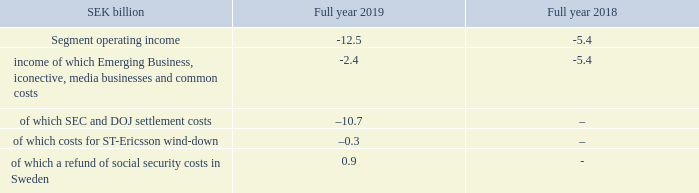Operating income increased to SEK 2.3 (1.1) billion. Operating income excluding restructur- ing charges improved to SEK 2.4 (1.4) billion due to a positive effect from reversal of a provision for impairment of trade receivables made in Q1 2019, of SEK 0.7 billion, and higher gross margin.
Operating margin was 6.3%, excluding restructuring charges and the positive effect from reversal of a provision for impairment of trade receivables of SEK 0.7 billion in Q1 2019.
Restructuring charges amounted to SEK 0.0 (–0.3) billion.
Emerging Business and Other
Segment Emerging Business and Other represented 3% (4%) of Group net sales in 2019.
The segment includes:
–– Emerging Business, including IoT, iconectiv
and New businesses
–– Media businesses, including Red Bee
Media and a 49% ownership of MediaKind.
Net sales
Reported sales decreased by –19% in 2019 due to the 51% divestment of MediaKind in February 2019. Sales adjusted for comparable units and currency increased by 14% driven by growth in the iconectiv business through a multi-year number portability contract in the US.
Gross margin
Gross margin declined mainly due to the 51% divestment of MediaKind. The decline was partly offset by lower restructuring charges.
Operating income (loss)
Operating income was impacted by costs of SEK –10.7 billion related to the resolution of the US SEC and DOJ investigations, a refund of earlier paid social security costs in Sweden of SEK 0.9 billion and by costs of SEK –0.3
billion related to the wind-down of the ST-Ericsson legal structure.
Operating income in Emerging Business, iconectiv and common costs improved, driven by profitable growth in iconectiv. Red Bee Media income improved supported by profit improvement activities. Media Solutions income improved driven by the 51% divestment of Media Kind, including a capital gain from the transaction.
What is the reason that gross margin declined? The 51% divestment of mediakind. What is the full year 2018 operating income?
Answer scale should be: billion. -5.4. What is the full year 2019 operating income?
Answer scale should be: billion. -12.5. What is the total segment operating income for 2019 and 2018?
Answer scale should be: billion. -12.5+(-5.4)
Answer: -17.9. What is the change in income from Emerging Business, iconective, media businesses and common costs in 2019 and 2018?
Answer scale should be: billion. -2.4-(-5.4)
Answer: 3. What is the proportion of sec and doj settlement costs in its segment operating income in 2019?
Answer scale should be: percent. -10.7/-12.5
Answer: 85.6. 